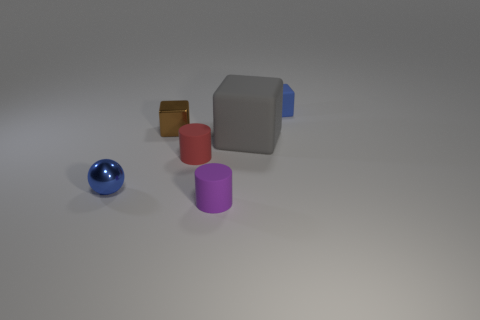Add 1 large purple metal objects. How many objects exist? 7 Subtract all blue blocks. How many blocks are left? 2 Subtract all cylinders. How many objects are left? 4 Subtract 2 blocks. How many blocks are left? 1 Subtract all brown cubes. How many cubes are left? 2 Subtract 0 green cubes. How many objects are left? 6 Subtract all gray cubes. Subtract all brown balls. How many cubes are left? 2 Subtract all red blocks. How many red cylinders are left? 1 Subtract all gray objects. Subtract all tiny red matte objects. How many objects are left? 4 Add 1 tiny blue rubber things. How many tiny blue rubber things are left? 2 